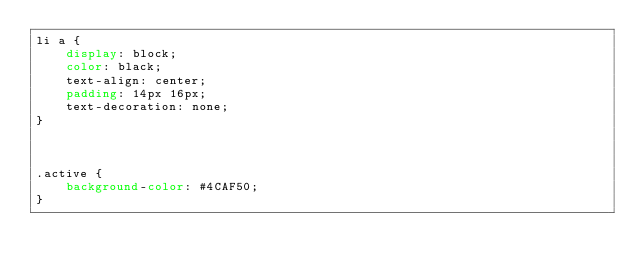Convert code to text. <code><loc_0><loc_0><loc_500><loc_500><_CSS_>li a {
    display: block;
    color: black;
    text-align: center;
    padding: 14px 16px;
    text-decoration: none;
}



.active {
    background-color: #4CAF50;
}</code> 